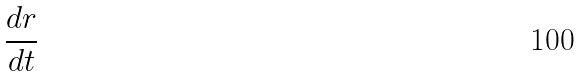Convert formula to latex. <formula><loc_0><loc_0><loc_500><loc_500>\frac { d r } { d t }</formula> 